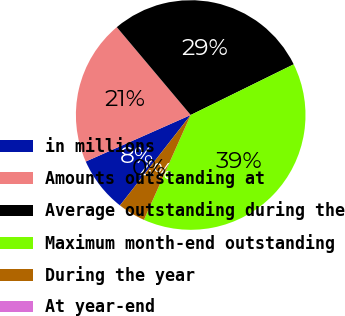Convert chart. <chart><loc_0><loc_0><loc_500><loc_500><pie_chart><fcel>in millions<fcel>Amounts outstanding at<fcel>Average outstanding during the<fcel>Maximum month-end outstanding<fcel>During the year<fcel>At year-end<nl><fcel>7.79%<fcel>20.51%<fcel>28.85%<fcel>38.95%<fcel>3.89%<fcel>0.0%<nl></chart> 